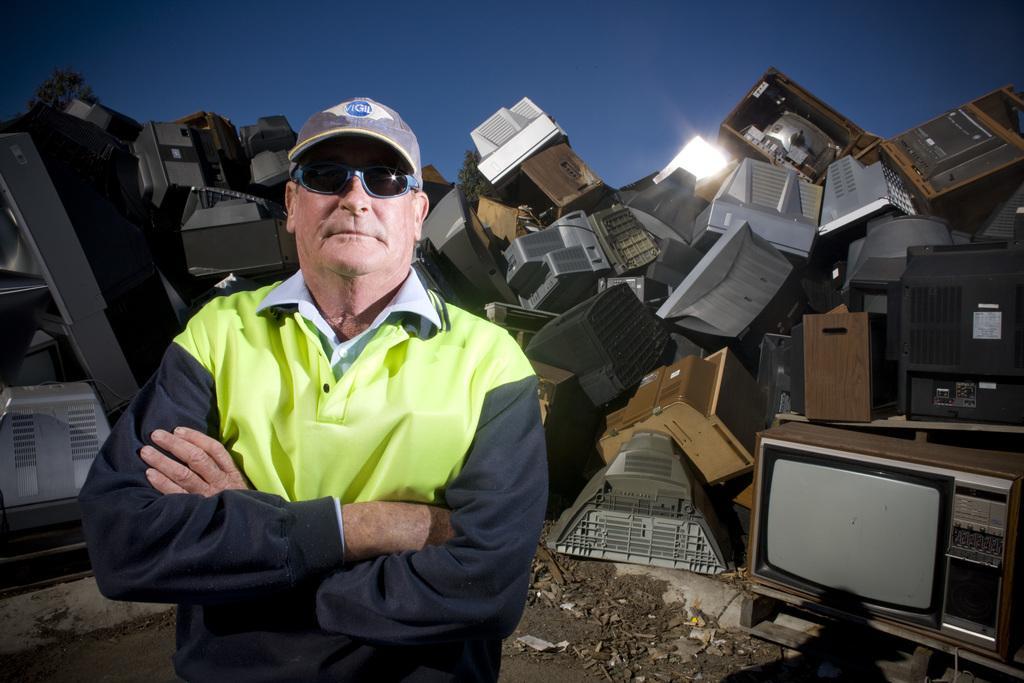Describe this image in one or two sentences. In this image there is the sky, there are objects on the ground, there are objects truncated towards the left of the image, there are objects truncated towards the right of the image, there is a person standing, there is a light. 